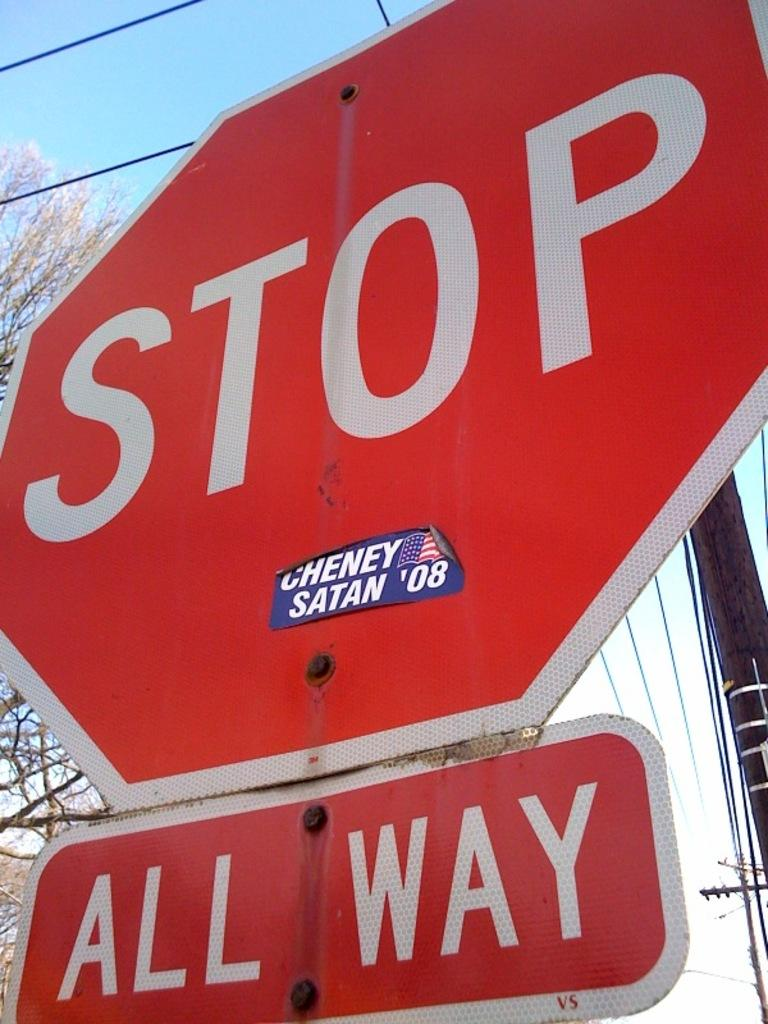<image>
Share a concise interpretation of the image provided. A large red sign says Stop and has a Cheney Satan '08 sticker on it. 